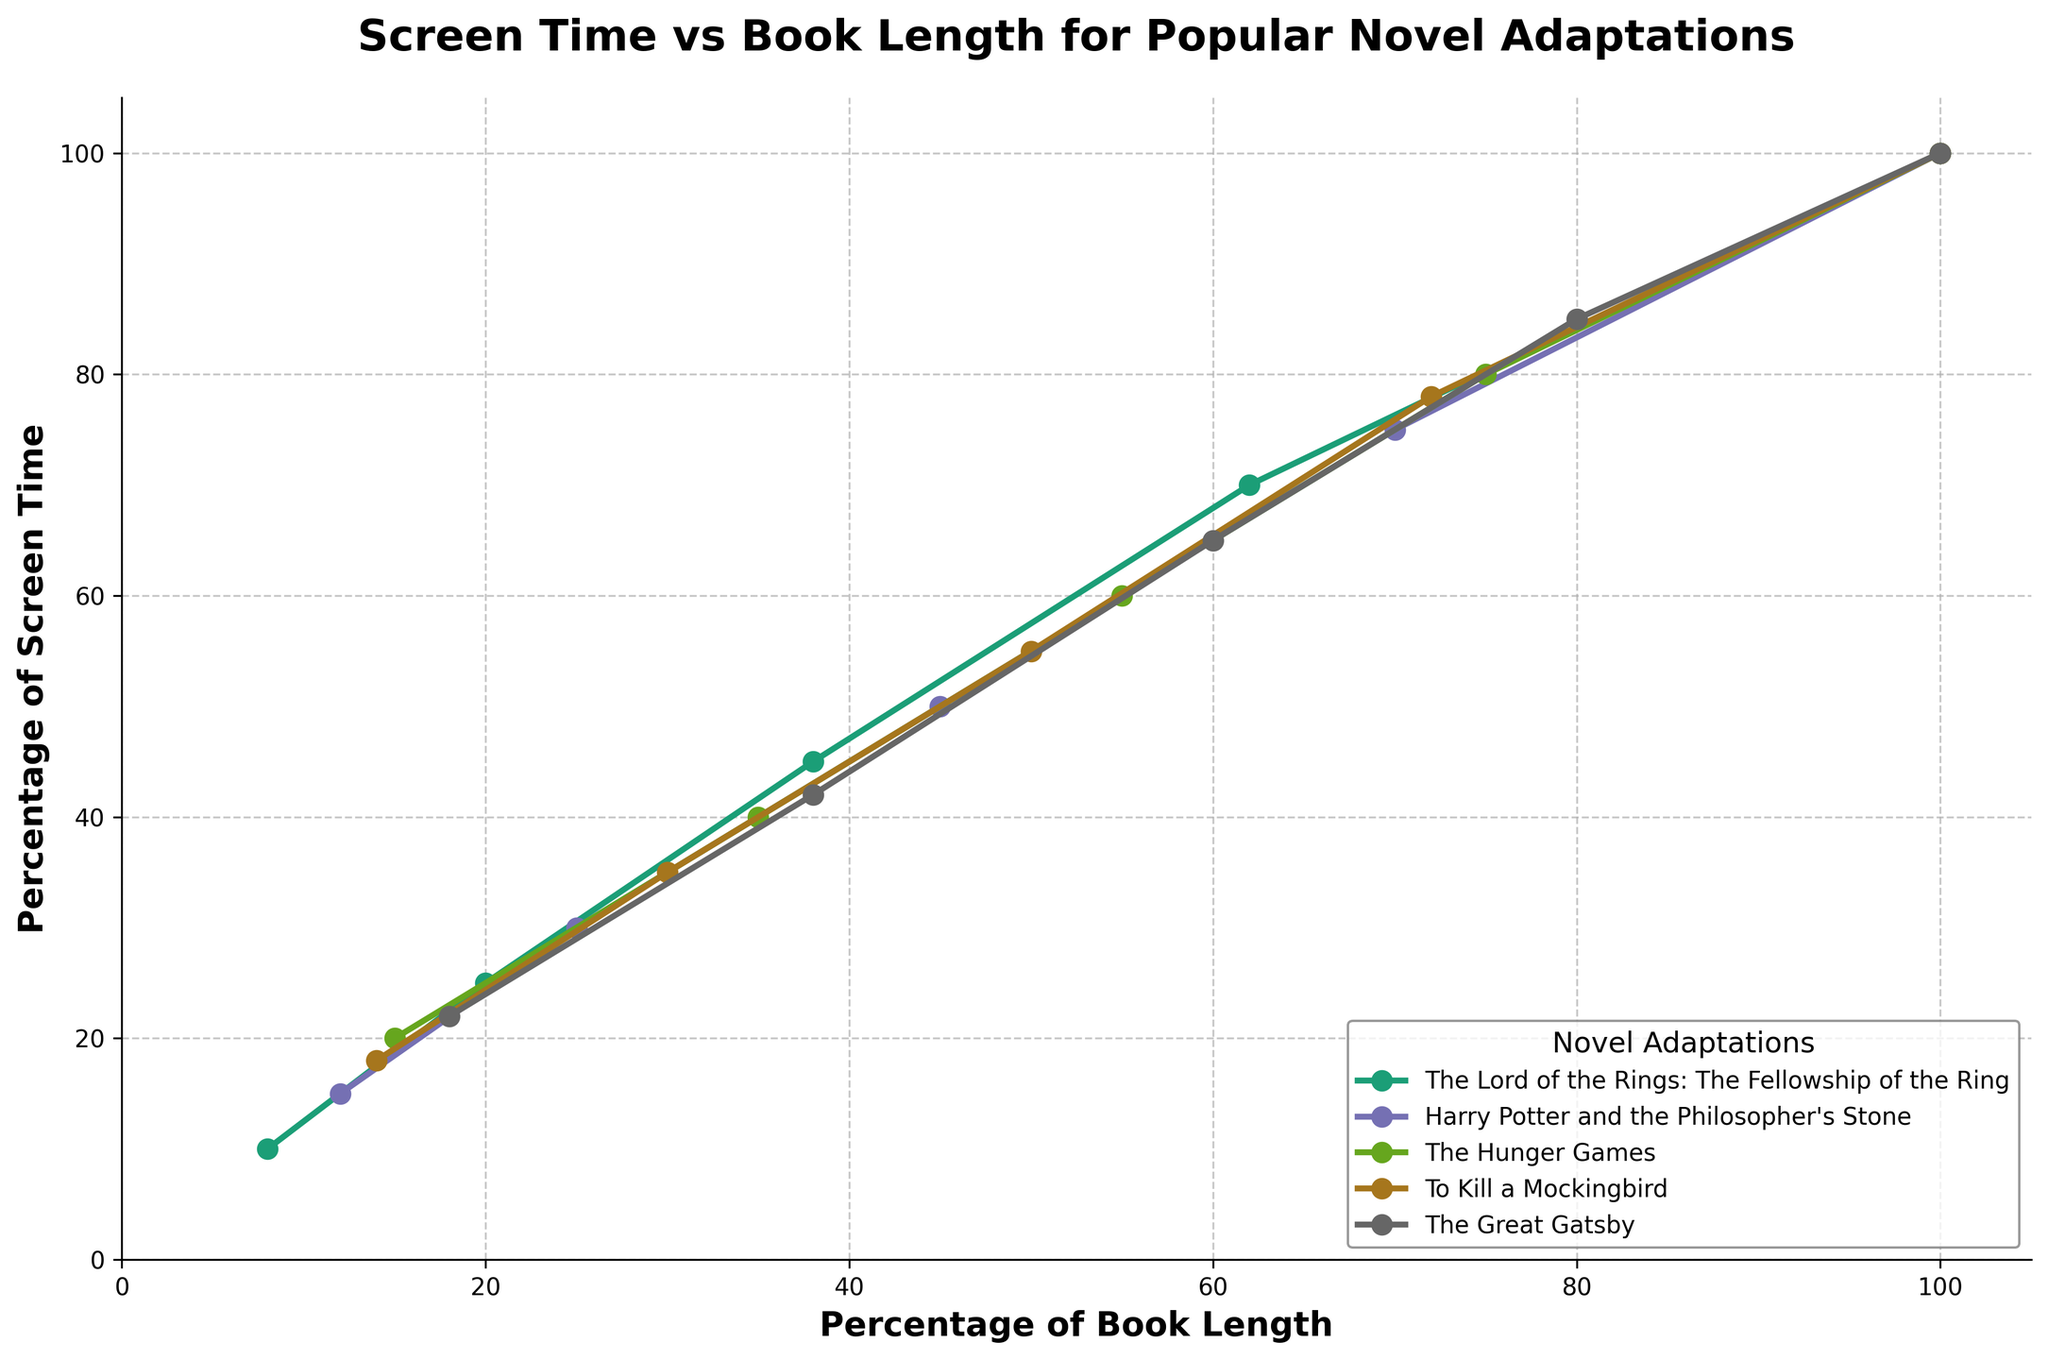Which book adaptation has the greatest alignment between the percentage of screen time and the percentage of book length? To determine which book adaptation has the greatest alignment, we can look at the points on the line chart where the percentage of screen time matches closely with the percentage of book length. From the figure, "The Lord of the Rings: The Fellowship of the Ring" and "The Hunger Games" show a close alignment, but "Harry Potter and the Philosopher's Stone" seems to match more consistently across several points.
Answer: Harry Potter and the Philosopher's Stone Which book adaptation dedicates more screen time relative to its book length between 25% and 30%? We compare the screen time and book length percentages for the books at around 25% and 30% of book length. "The Lord of the Rings: The Fellowship of the Ring" at 25% book length is 25% screen time, whereas "Harry Potter and the Philosopher's Stone" at 30% book length is 30% screen time. Thus, "Harry Potter and the Philosopher's Stone" dedicates more screen time.
Answer: Harry Potter and the Philosopher's Stone At 50% of the book length, which adaptation has the highest percentage of screen time? We examine the points corresponding to 50% of the book length for each adaptation. From the chart, "Harry Potter and the Philosopher's Stone" at 50% of book length has 50% screen time, "The Hunger Games" has 60% screen time, and "To Kill a Mockingbird" has 55% screen time. Thus, "The Hunger Games" has the highest percentage of screen time at 50% book length.
Answer: The Hunger Games Which adaptation shows the most deviation from the diagonal line (where screen time would equal book length percentage) at 20% of book length? To find this, check the deviation at 20% for the adaptations. "The Lord of the Rings: The Fellowship of the Ring" at 20% book length has 25% screen time, "Harry Potter and the Philosopher's Stone" and "The Hunger Games" do not list 20%, but the closest points show less deviation considering "Harry Potter and the Philosopher's Stone" at 15% vs. "The Great Gatsby" at 22%. Hence, "The Lord of the Rings: The Fellowship of the Ring" shows the most deviation.
Answer: The Lord of the Rings: The Fellowship of the Ring What is the average percentage increase in screen time from 20% to 50% book length for "The Hunger Games"? First, calculate the percentage of screen time at 20% (15%) and 50% (55%) book length. The increase is 55% - 15% = 40%. To find the average percentage increase per 10% increment of book length, divide 40% by the 3 intervals (30%, calculating 10% each for intervals between 20 to 50). 40% / 3 ≈ 13.33%
Answer: 13.33% Between 60% and 80% of book length, which adaptation dedicates the most screen time? Review the chart at 60% and 80% points. At 60%, "The Hunger Games" and "To Kill a Mockingbird" are closest, but "The Great Gatsby" aligns more. At 80%, "The Great Gatsby" devotes 85% screen time, more than others, making it highest.
Answer: The Great Gatsby How does the screen time of "The Great Gatsby" at 65% book length compare to "To Kill a Mockingbird" at the same length? For 65% book length, "The Great Gatsby" has 65% screen time. "To Kill a Mockingbird" does not show 65% on the plot, but 72% at 78% book length, estimating < 72% at 65% book length. Thus, “The Great Gatsby” has more screen time.
Answer: The Great Gatsby Which adaptation shows a consistent increase in screen time with book length percentages closer to 1:1 ratio? Examine the plots for consistent proportional increases. "The Lord of the Rings: The Fellowship of the Ring" starts deviating earlier, while "The Hunger Games" and "Harry Potter and the Philosopher’s Stone" remain consistent across most segments, with "Harry Potter and the Philosopher's Stone" more consistent overall.
Answer: Harry Potter and the Philosopher's Stone 